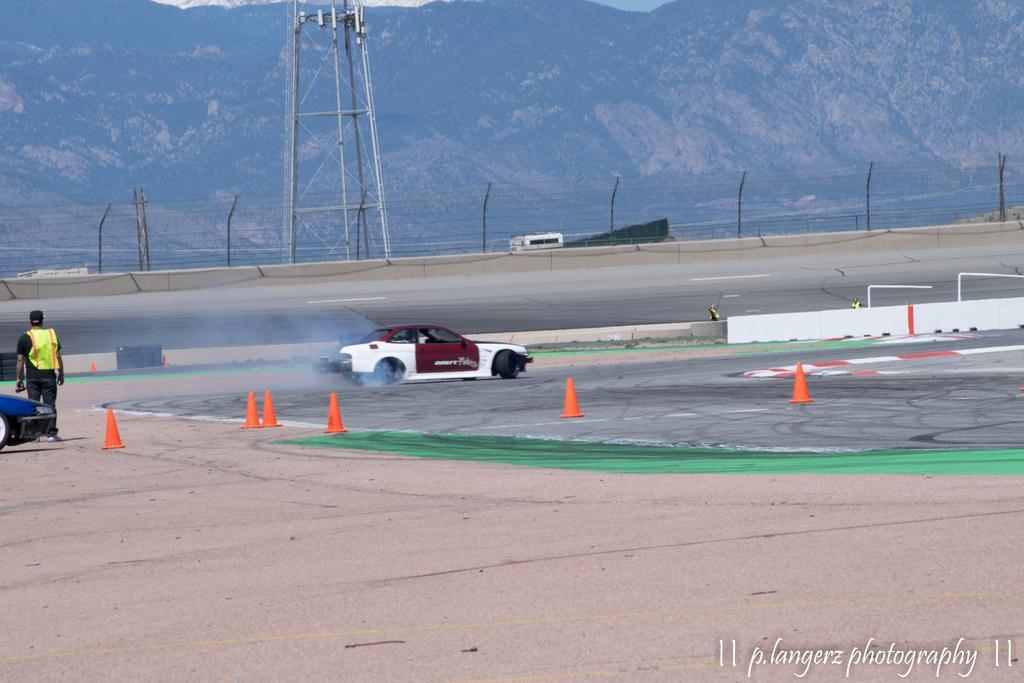Can you describe this image briefly? In this picture we can see a person and a car on the left side, there are traffic cones and another car in the middle, in the background there is a tower, fencing and a hill, there is some text at the right bottom. 